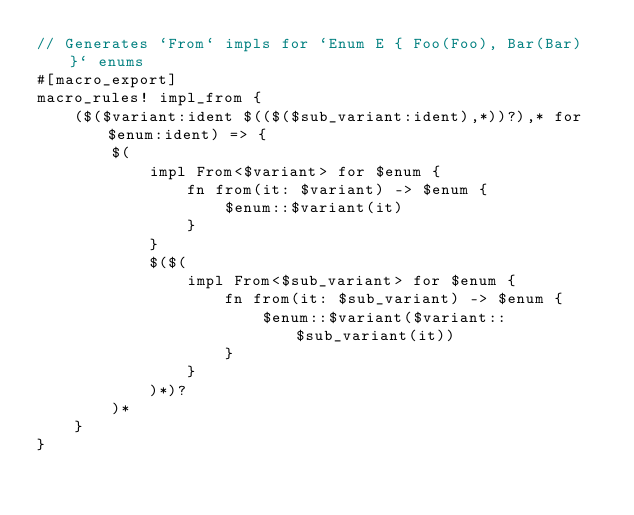<code> <loc_0><loc_0><loc_500><loc_500><_Rust_>// Generates `From` impls for `Enum E { Foo(Foo), Bar(Bar) }` enums
#[macro_export]
macro_rules! impl_from {
    ($($variant:ident $(($($sub_variant:ident),*))?),* for $enum:ident) => {
        $(
            impl From<$variant> for $enum {
                fn from(it: $variant) -> $enum {
                    $enum::$variant(it)
                }
            }
            $($(
                impl From<$sub_variant> for $enum {
                    fn from(it: $sub_variant) -> $enum {
                        $enum::$variant($variant::$sub_variant(it))
                    }
                }
            )*)?
        )*
    }
}
</code> 